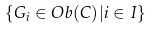Convert formula to latex. <formula><loc_0><loc_0><loc_500><loc_500>\{ G _ { i } \in O b ( C ) | i \in I \}</formula> 